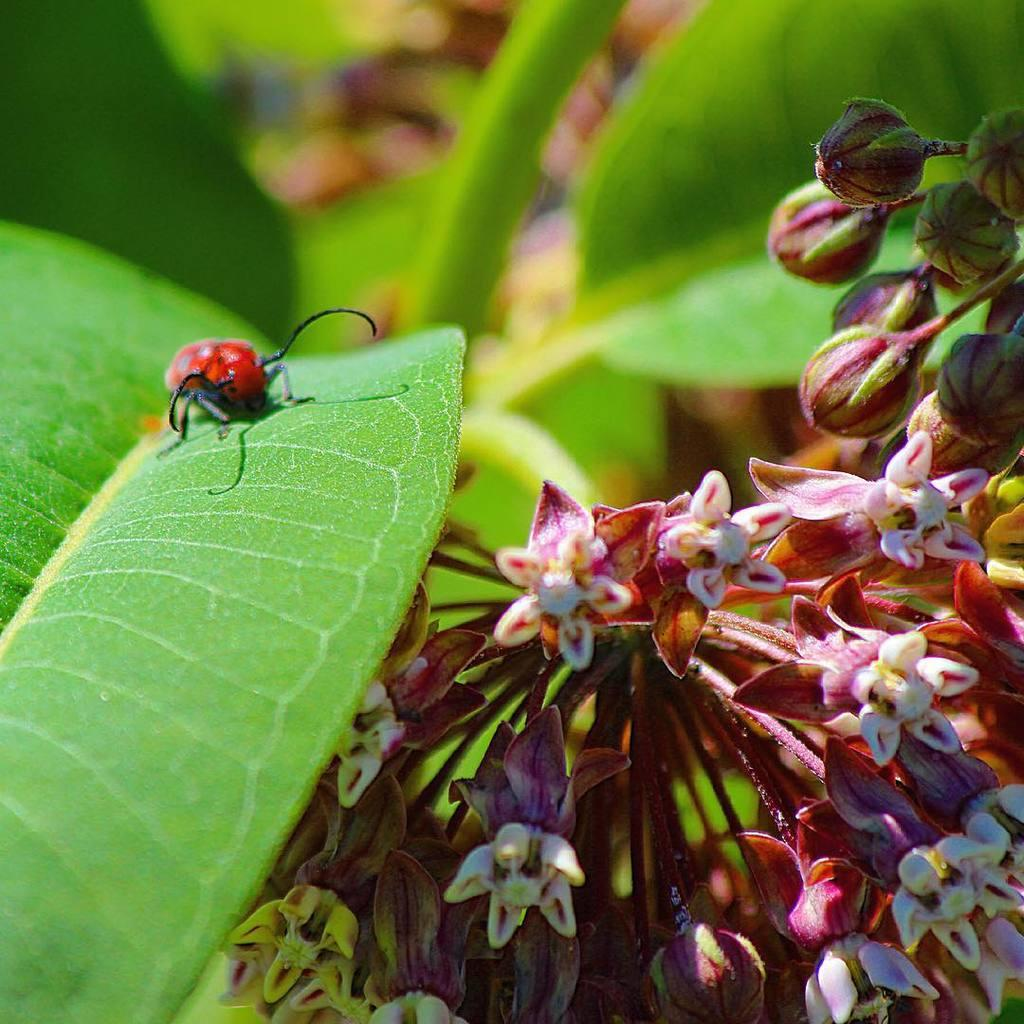What is present on the leaf in the image? There is an insect on a leaf in the image. What other elements can be seen near the leaf? There are flowers beside the leaf in the image. What type of rifle can be seen in the image? There is no rifle present in the image; it features an insect on a leaf and flowers beside the leaf. What kind of horn is visible on the ground in the image? There is no horn present in the image; it only contains an insect on a leaf and flowers beside the leaf. 